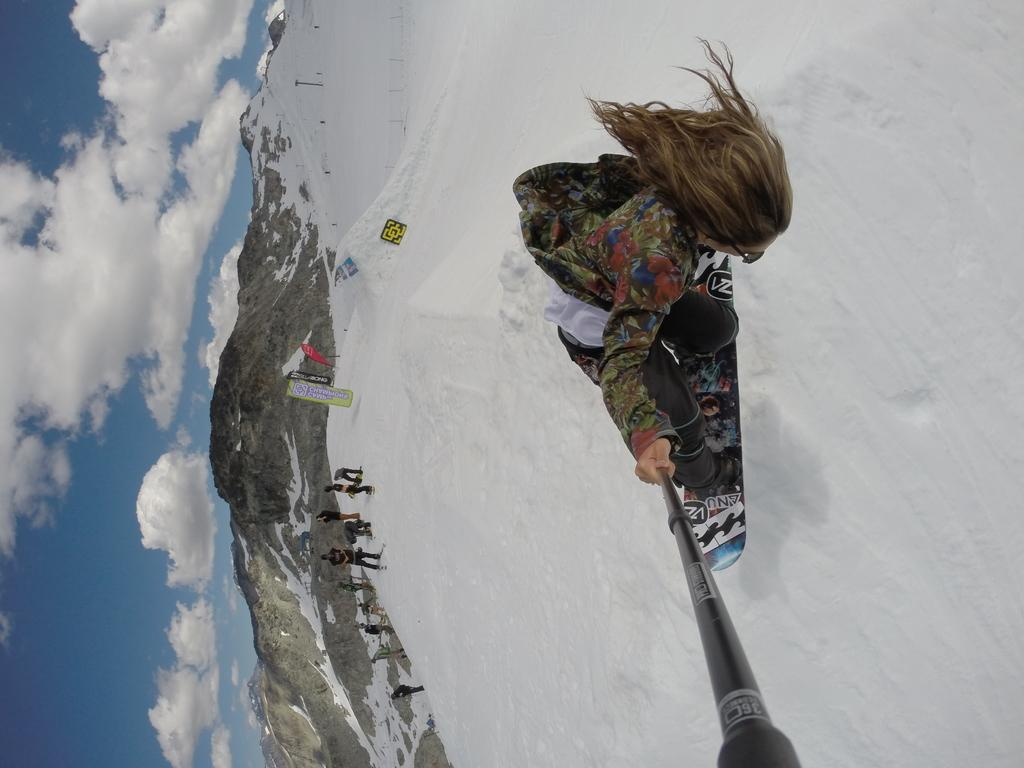How many people are in the image? There are people in the image, but the exact number is not specified. What is the surface the people are standing on? The people are on snow in the image. What activity is one of the people engaged in? One person is skiing in the image. What is the person skiing holding? The person skiing is holding a stick in the image. What type of signage is present in the image? There are boards with text in the image. What type of landscape can be seen in the image? Mountains are visible in the image. What part of the natural environment is visible in the image? The sky is visible in the image. How many cubs can be seen playing with water in the image? There are no cubs or water present in the image. 